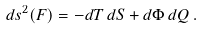<formula> <loc_0><loc_0><loc_500><loc_500>d s ^ { 2 } ( F ) = - d T \, d S + d \Phi \, d Q \, .</formula> 